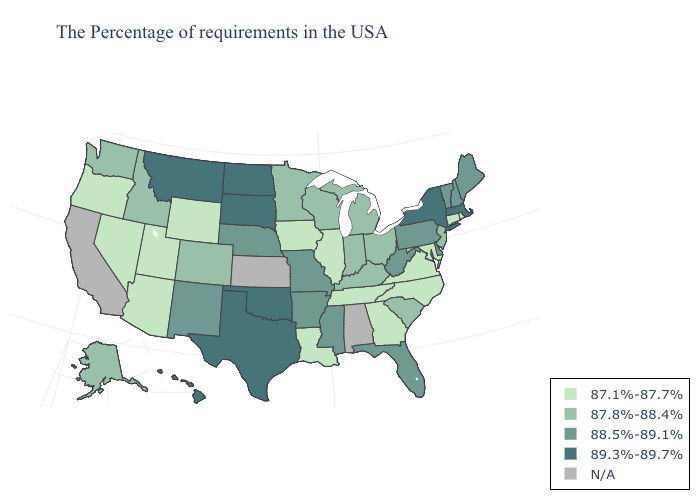Which states have the lowest value in the South?
Write a very short answer. Maryland, Virginia, North Carolina, Georgia, Tennessee, Louisiana. What is the value of Oregon?
Answer briefly. 87.1%-87.7%. What is the highest value in states that border Nevada?
Be succinct. 87.8%-88.4%. Name the states that have a value in the range 89.3%-89.7%?
Short answer required. Massachusetts, New York, Oklahoma, Texas, South Dakota, North Dakota, Montana, Hawaii. Among the states that border South Carolina , which have the lowest value?
Quick response, please. North Carolina, Georgia. What is the lowest value in the USA?
Quick response, please. 87.1%-87.7%. What is the value of New Jersey?
Answer briefly. 87.8%-88.4%. Name the states that have a value in the range 87.1%-87.7%?
Keep it brief. Rhode Island, Connecticut, Maryland, Virginia, North Carolina, Georgia, Tennessee, Illinois, Louisiana, Iowa, Wyoming, Utah, Arizona, Nevada, Oregon. What is the highest value in the USA?
Give a very brief answer. 89.3%-89.7%. Name the states that have a value in the range 89.3%-89.7%?
Be succinct. Massachusetts, New York, Oklahoma, Texas, South Dakota, North Dakota, Montana, Hawaii. Which states have the lowest value in the South?
Write a very short answer. Maryland, Virginia, North Carolina, Georgia, Tennessee, Louisiana. Name the states that have a value in the range 87.8%-88.4%?
Be succinct. New Jersey, South Carolina, Ohio, Michigan, Kentucky, Indiana, Wisconsin, Minnesota, Colorado, Idaho, Washington, Alaska. Among the states that border Ohio , which have the lowest value?
Be succinct. Michigan, Kentucky, Indiana. 